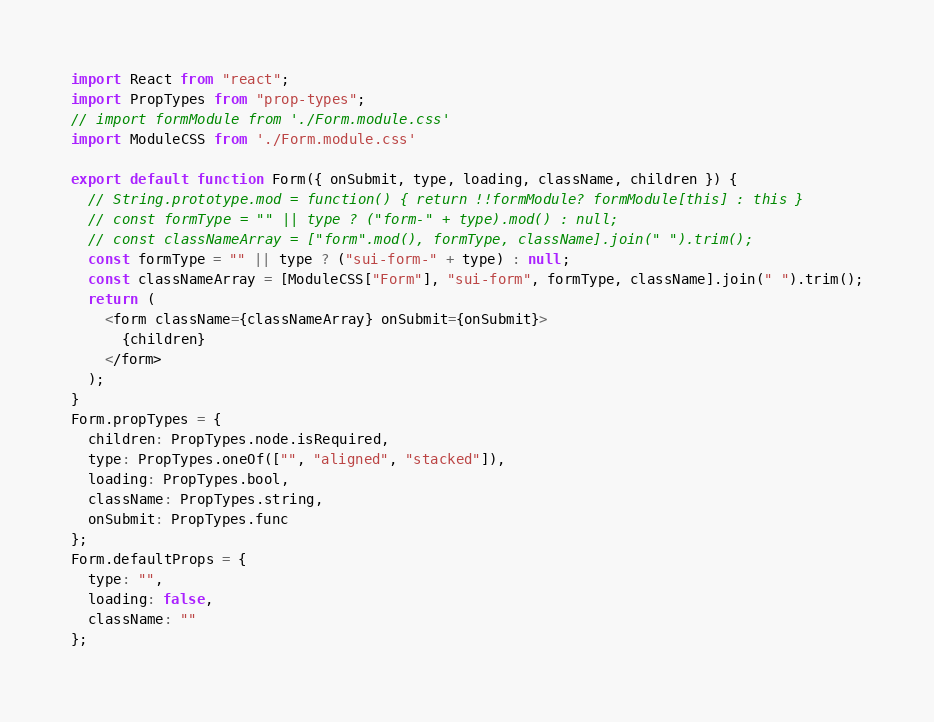Convert code to text. <code><loc_0><loc_0><loc_500><loc_500><_JavaScript_>import React from "react";
import PropTypes from "prop-types";
// import formModule from './Form.module.css'
import ModuleCSS from './Form.module.css'

export default function Form({ onSubmit, type, loading, className, children }) {
  // String.prototype.mod = function() { return !!formModule? formModule[this] : this }
  // const formType = "" || type ? ("form-" + type).mod() : null;
  // const classNameArray = ["form".mod(), formType, className].join(" ").trim();
  const formType = "" || type ? ("sui-form-" + type) : null;
  const classNameArray = [ModuleCSS["Form"], "sui-form", formType, className].join(" ").trim();
  return (
    <form className={classNameArray} onSubmit={onSubmit}>
      {children}
    </form>
  );
}
Form.propTypes = {
  children: PropTypes.node.isRequired,
  type: PropTypes.oneOf(["", "aligned", "stacked"]),
  loading: PropTypes.bool,
  className: PropTypes.string,
  onSubmit: PropTypes.func
};
Form.defaultProps = {
  type: "",
  loading: false,
  className: ""
};
</code> 